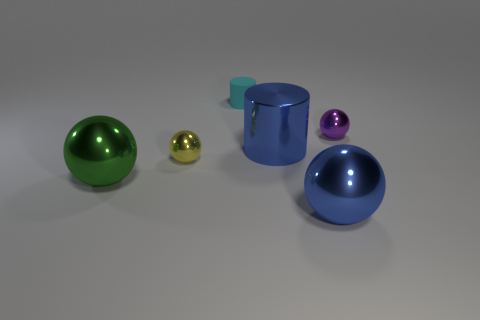Subtract all cylinders. How many objects are left? 4 Add 1 shiny things. How many objects exist? 7 Subtract all purple spheres. How many spheres are left? 3 Subtract 1 blue spheres. How many objects are left? 5 Subtract 1 cylinders. How many cylinders are left? 1 Subtract all green balls. Subtract all green cylinders. How many balls are left? 3 Subtract all red cubes. How many green balls are left? 1 Subtract all small cylinders. Subtract all blue cylinders. How many objects are left? 4 Add 1 large blue metal cylinders. How many large blue metal cylinders are left? 2 Add 5 blue objects. How many blue objects exist? 7 